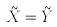<formula> <loc_0><loc_0><loc_500><loc_500>\tilde { X } = \tilde { Y }</formula> 